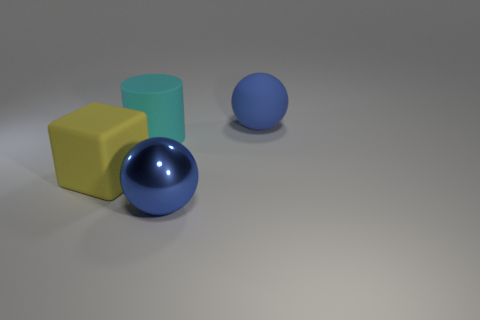Add 2 tiny gray matte cylinders. How many objects exist? 6 Subtract all blocks. How many objects are left? 3 Subtract 0 purple cylinders. How many objects are left? 4 Subtract all large blue spheres. Subtract all big yellow matte things. How many objects are left? 1 Add 1 yellow blocks. How many yellow blocks are left? 2 Add 3 red objects. How many red objects exist? 3 